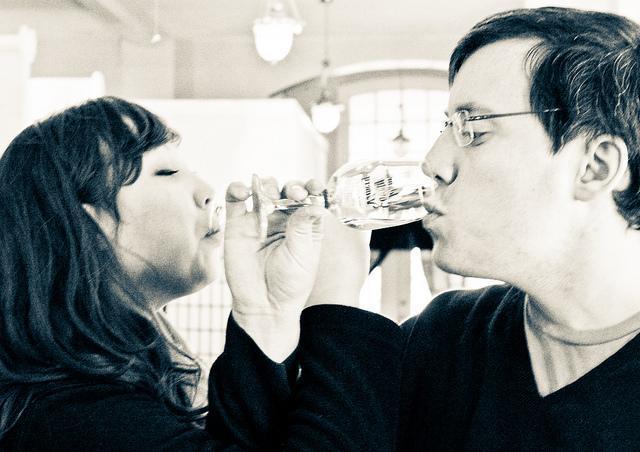How many light fixtures are in the picture?
Give a very brief answer. 3. How many men are in the picture?
Give a very brief answer. 1. How many men are holding beverages?
Give a very brief answer. 1. How many people can be seen?
Give a very brief answer. 2. How many wine glasses are there?
Give a very brief answer. 2. 